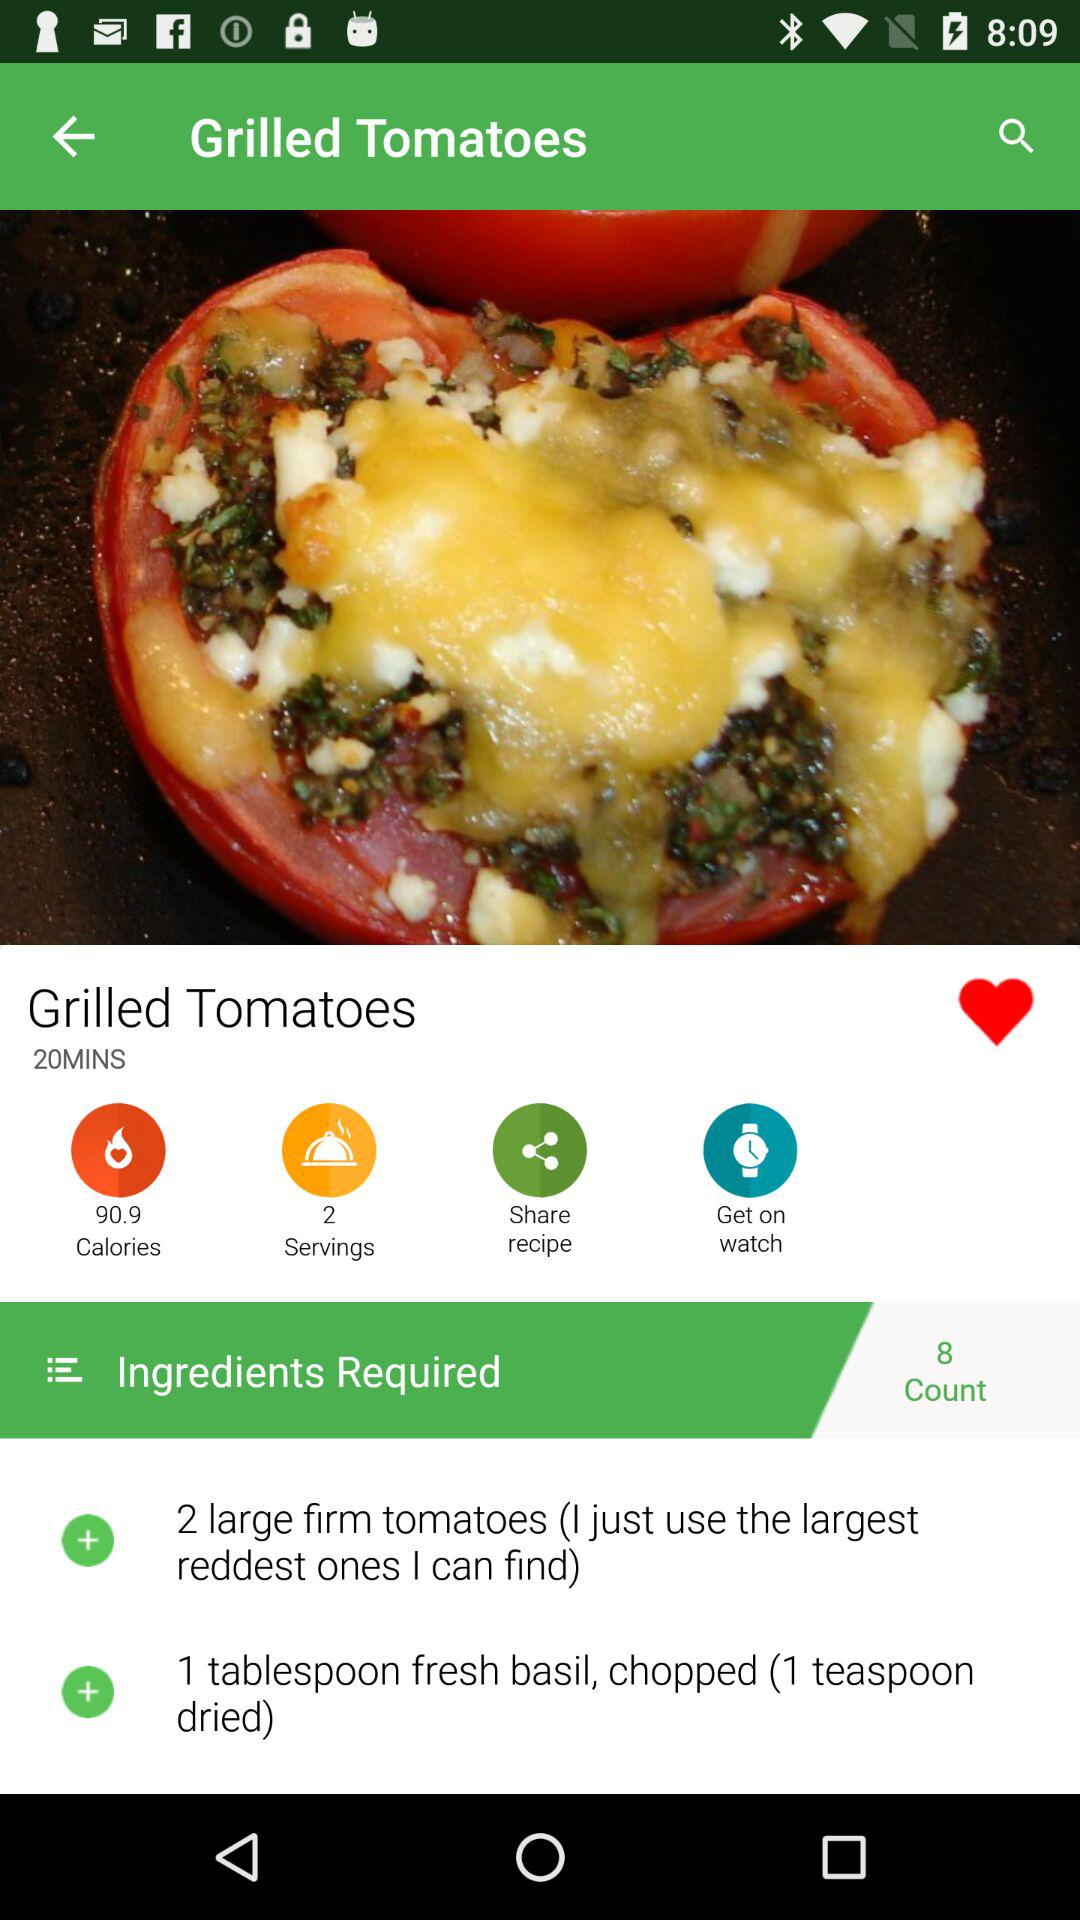What is the name of the recipe? The name of the recipe is "Grilled Tomatoes". 